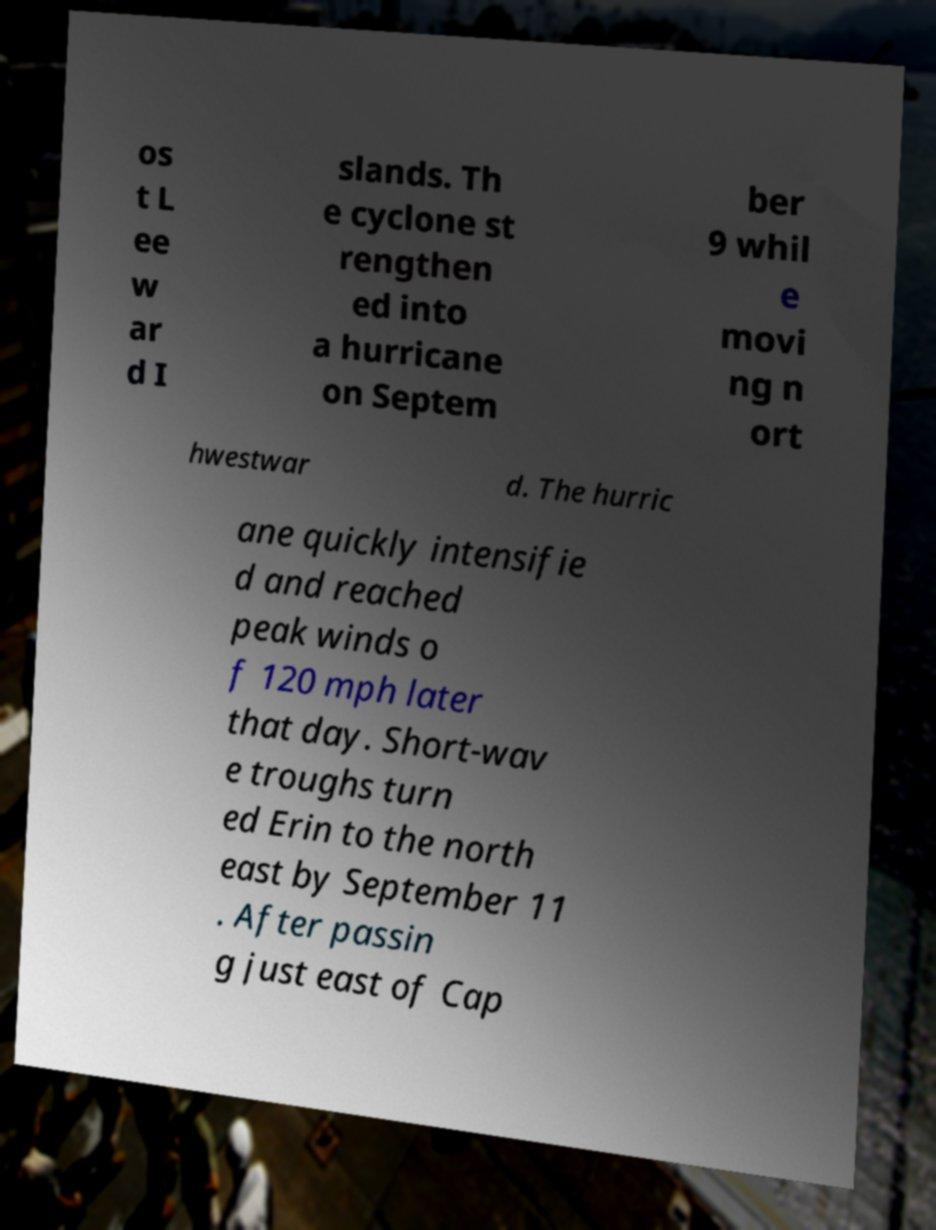Can you accurately transcribe the text from the provided image for me? os t L ee w ar d I slands. Th e cyclone st rengthen ed into a hurricane on Septem ber 9 whil e movi ng n ort hwestwar d. The hurric ane quickly intensifie d and reached peak winds o f 120 mph later that day. Short-wav e troughs turn ed Erin to the north east by September 11 . After passin g just east of Cap 